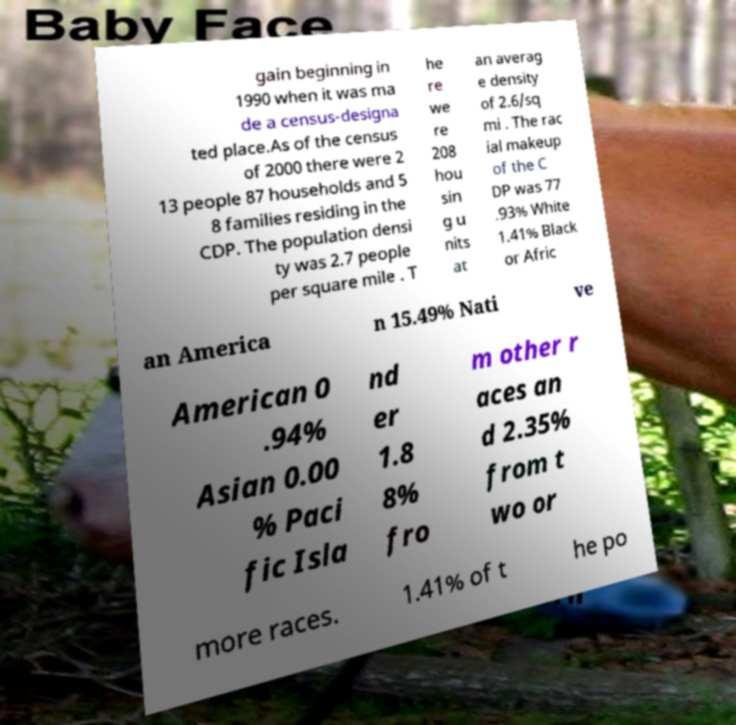Could you extract and type out the text from this image? gain beginning in 1990 when it was ma de a census-designa ted place.As of the census of 2000 there were 2 13 people 87 households and 5 8 families residing in the CDP. The population densi ty was 2.7 people per square mile . T he re we re 208 hou sin g u nits at an averag e density of 2.6/sq mi . The rac ial makeup of the C DP was 77 .93% White 1.41% Black or Afric an America n 15.49% Nati ve American 0 .94% Asian 0.00 % Paci fic Isla nd er 1.8 8% fro m other r aces an d 2.35% from t wo or more races. 1.41% of t he po 